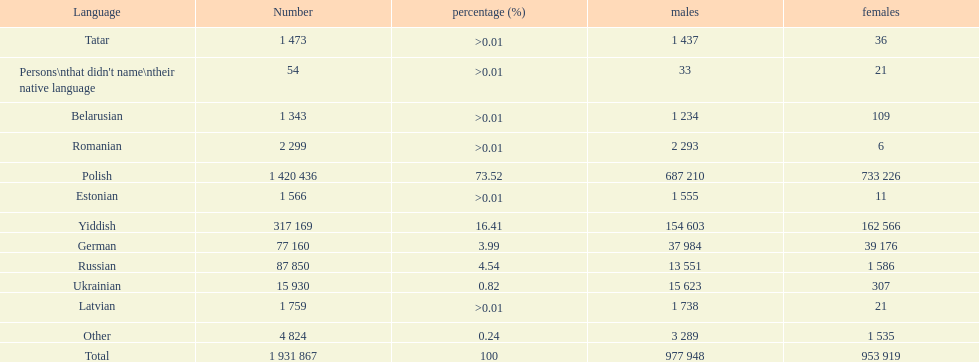Can you parse all the data within this table? {'header': ['Language', 'Number', 'percentage (%)', 'males', 'females'], 'rows': [['Tatar', '1 473', '>0.01', '1 437', '36'], ["Persons\\nthat didn't name\\ntheir native language", '54', '>0.01', '33', '21'], ['Belarusian', '1 343', '>0.01', '1 234', '109'], ['Romanian', '2 299', '>0.01', '2 293', '6'], ['Polish', '1 420 436', '73.52', '687 210', '733 226'], ['Estonian', '1 566', '>0.01', '1 555', '11'], ['Yiddish', '317 169', '16.41', '154 603', '162 566'], ['German', '77 160', '3.99', '37 984', '39 176'], ['Russian', '87 850', '4.54', '13 551', '1 586'], ['Ukrainian', '15 930', '0.82', '15 623', '307'], ['Latvian', '1 759', '>0.01', '1 738', '21'], ['Other', '4 824', '0.24', '3 289', '1 535'], ['Total', '1 931 867', '100', '977 948', '953 919']]} Is german above or below russia in the number of people who speak that language? Below. 